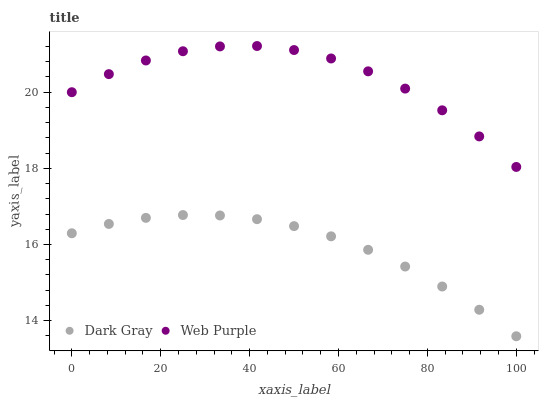Does Dark Gray have the minimum area under the curve?
Answer yes or no. Yes. Does Web Purple have the maximum area under the curve?
Answer yes or no. Yes. Does Web Purple have the minimum area under the curve?
Answer yes or no. No. Is Dark Gray the smoothest?
Answer yes or no. Yes. Is Web Purple the roughest?
Answer yes or no. Yes. Is Web Purple the smoothest?
Answer yes or no. No. Does Dark Gray have the lowest value?
Answer yes or no. Yes. Does Web Purple have the lowest value?
Answer yes or no. No. Does Web Purple have the highest value?
Answer yes or no. Yes. Is Dark Gray less than Web Purple?
Answer yes or no. Yes. Is Web Purple greater than Dark Gray?
Answer yes or no. Yes. Does Dark Gray intersect Web Purple?
Answer yes or no. No. 